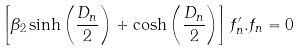Convert formula to latex. <formula><loc_0><loc_0><loc_500><loc_500>\left [ \beta _ { 2 } \sinh { \left ( \frac { D _ { n } } { 2 } \right ) } + \cosh { \left ( \frac { D _ { n } } { 2 } \right ) } \right ] f _ { n } ^ { \prime } . f _ { n } = 0</formula> 